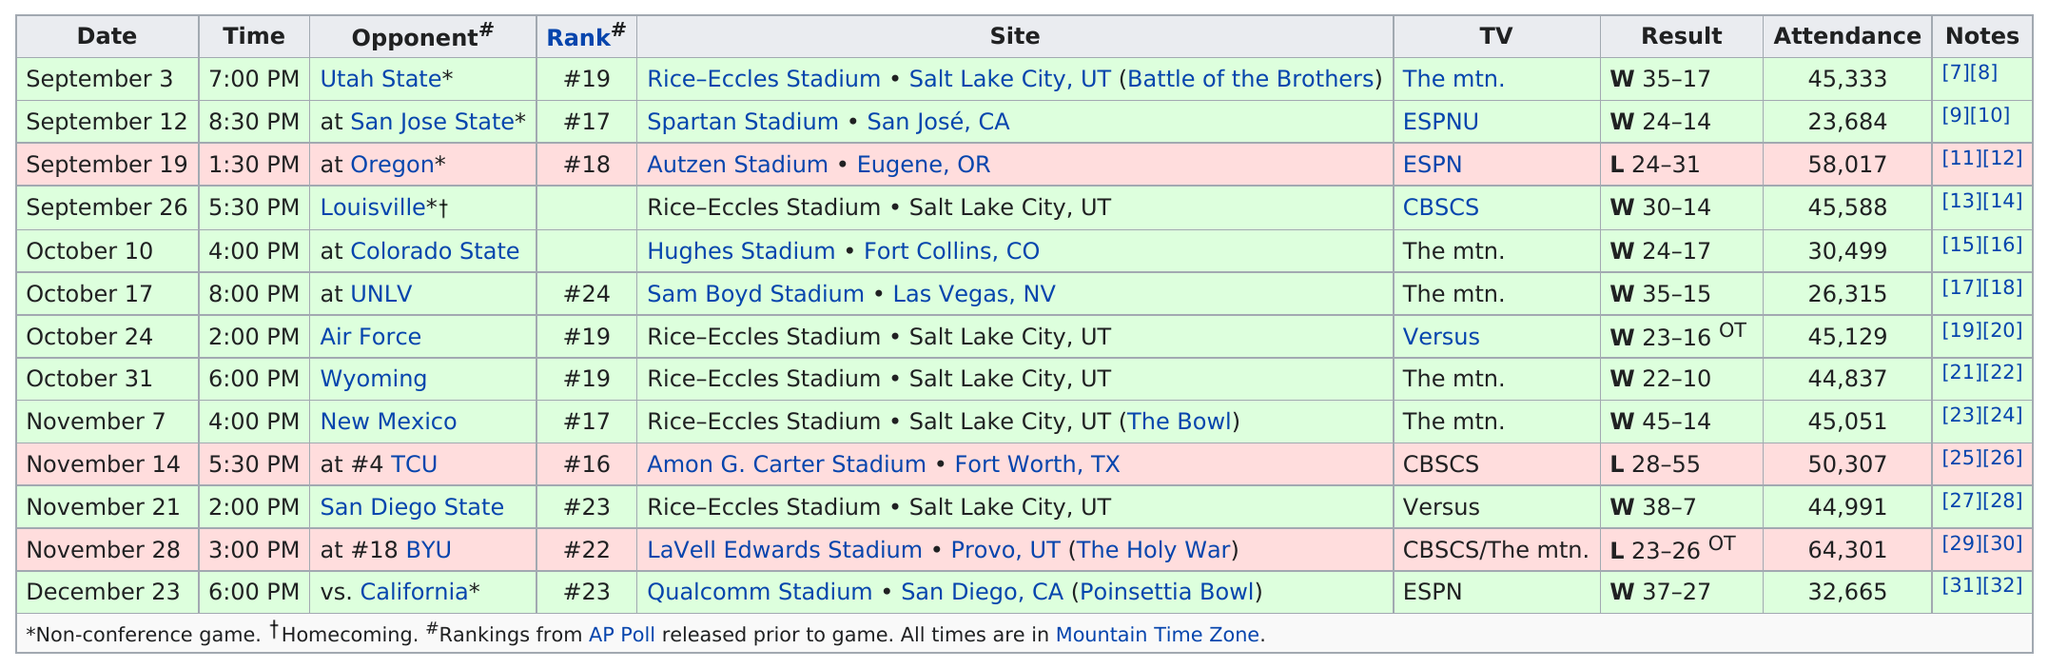Outline some significant characteristics in this image. The 2009 Utah Utes football team achieved a record of 10 victories in their games played during the season. The last football game of the Utah Utes in 2009 was played on December 23. On September 3, 2009, the first game of the Utah Utes football team's season was played. The first loss of the season occurred away from home. On November 21, the opponent scored only 7 points, and it was the game in which they did not perform well. 